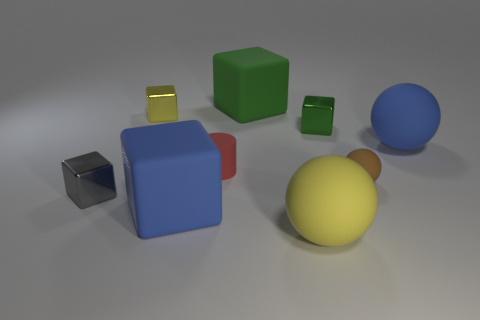Add 1 small brown matte blocks. How many objects exist? 10 Subtract 1 spheres. How many spheres are left? 2 Subtract all gray cubes. How many cubes are left? 4 Subtract all blue blocks. How many blocks are left? 4 Subtract all cylinders. How many objects are left? 8 Subtract all tiny purple metal things. Subtract all small yellow objects. How many objects are left? 8 Add 3 spheres. How many spheres are left? 6 Add 2 balls. How many balls exist? 5 Subtract 0 green cylinders. How many objects are left? 9 Subtract all yellow cubes. Subtract all red spheres. How many cubes are left? 4 